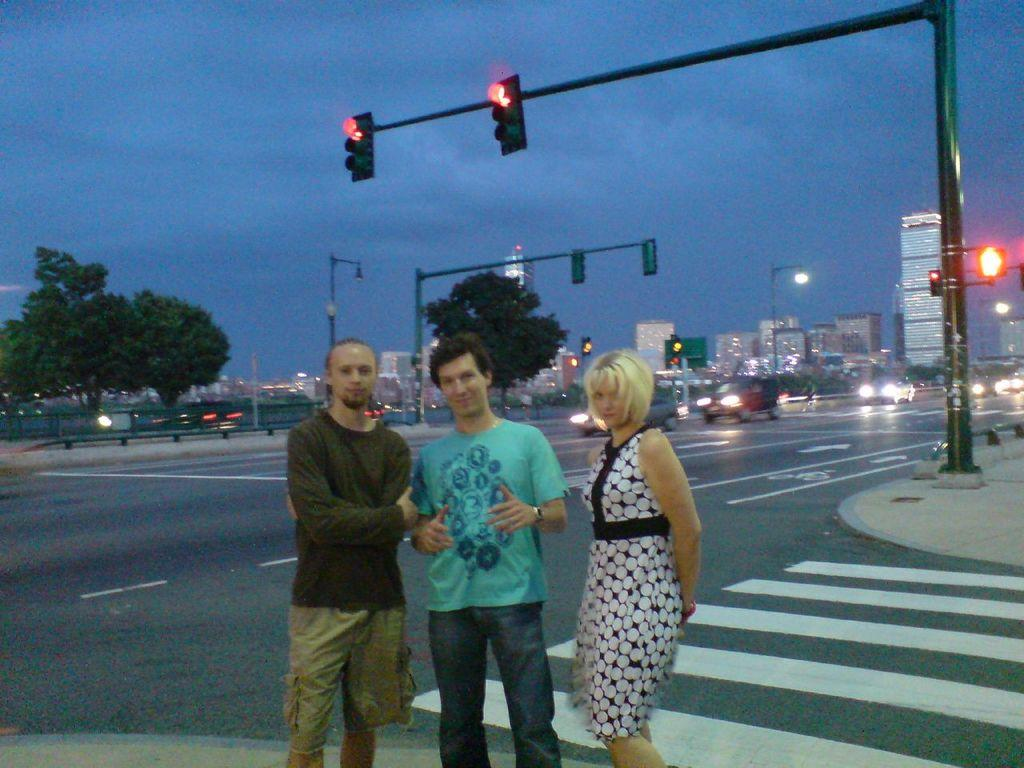What can be seen on the side of the road in the image? There are people standing by the side of the road in the image. What is happening on the road? There are vehicles on the road in the image. What helps regulate traffic in the image? Signal lights are present in the image. What can be seen in the distance in the image? There are buildings and trees visible in the background in the image. What type of cherry is the daughter holding in the image? There is no daughter or cherry present in the image. Is the lawyer in the image arguing a case? There is no lawyer or case being argued in the image. 